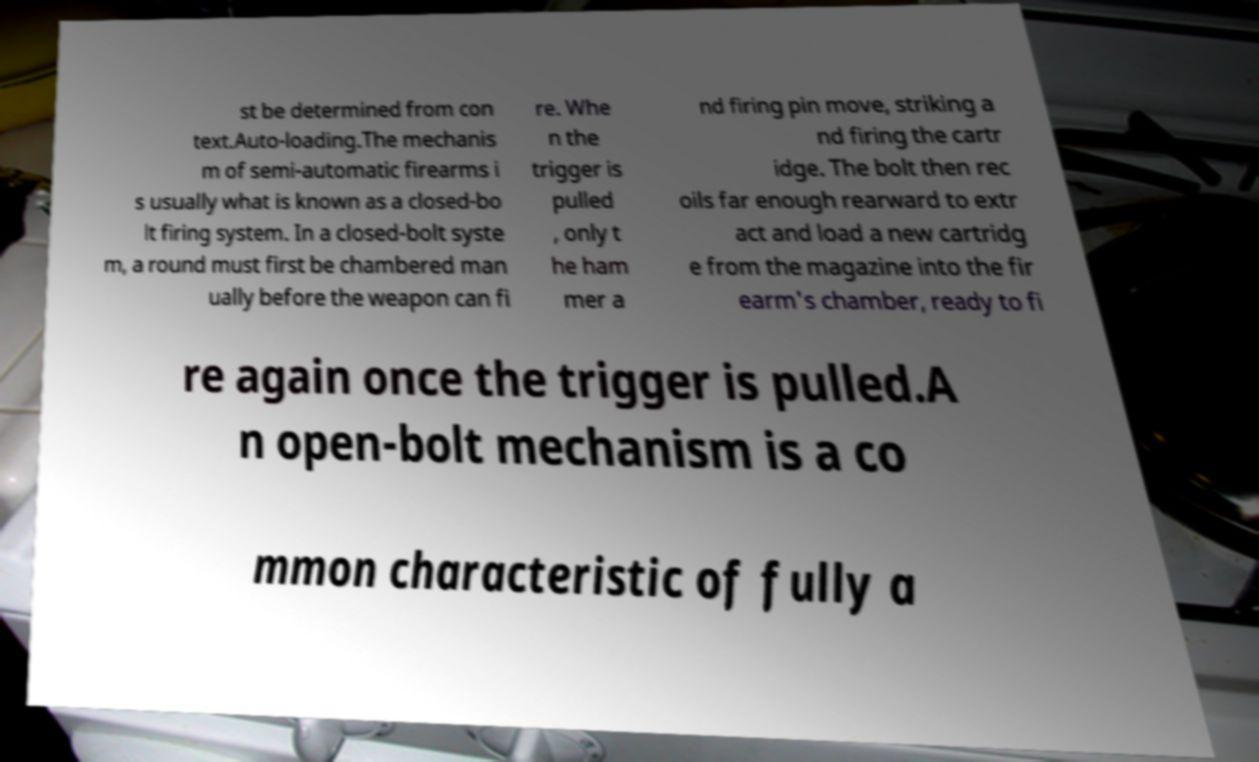Could you assist in decoding the text presented in this image and type it out clearly? st be determined from con text.Auto-loading.The mechanis m of semi-automatic firearms i s usually what is known as a closed-bo lt firing system. In a closed-bolt syste m, a round must first be chambered man ually before the weapon can fi re. Whe n the trigger is pulled , only t he ham mer a nd firing pin move, striking a nd firing the cartr idge. The bolt then rec oils far enough rearward to extr act and load a new cartridg e from the magazine into the fir earm's chamber, ready to fi re again once the trigger is pulled.A n open-bolt mechanism is a co mmon characteristic of fully a 